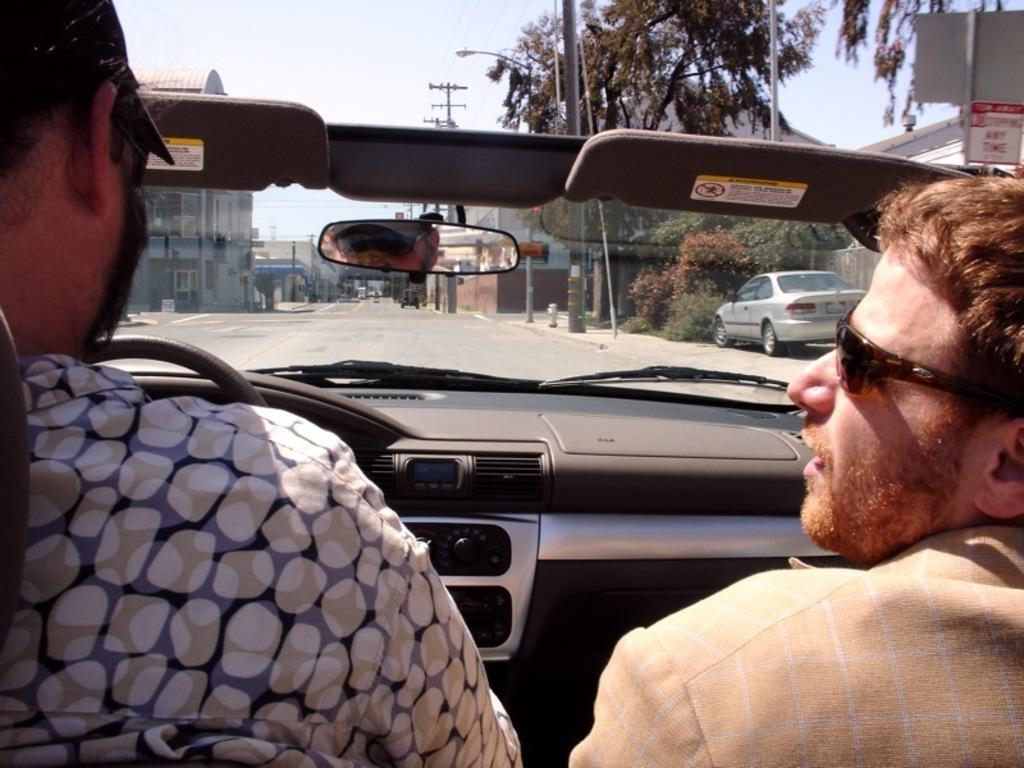How many people are in the car in the image? There are two people in the car in the image. Who is driving the car? The person on the left is driving the car. What can be seen in the front of the car? Trees, light poles, and electrical poles are visible in the front. What is the condition of the sky in the image? The sky is clear in the image. What type of goose is sitting on the hood of the car in the image? There is no goose present on the hood of the car in the image. What type of beef dish is being served in the car? There is no beef dish present in the car in the image. 